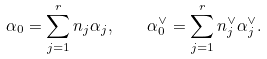Convert formula to latex. <formula><loc_0><loc_0><loc_500><loc_500>\alpha _ { 0 } = \sum _ { j = 1 } ^ { r } n _ { j } \alpha _ { j } , \quad \alpha _ { 0 } ^ { \vee } = \sum _ { j = 1 } ^ { r } n _ { j } ^ { \vee } \alpha _ { j } ^ { \vee } .</formula> 